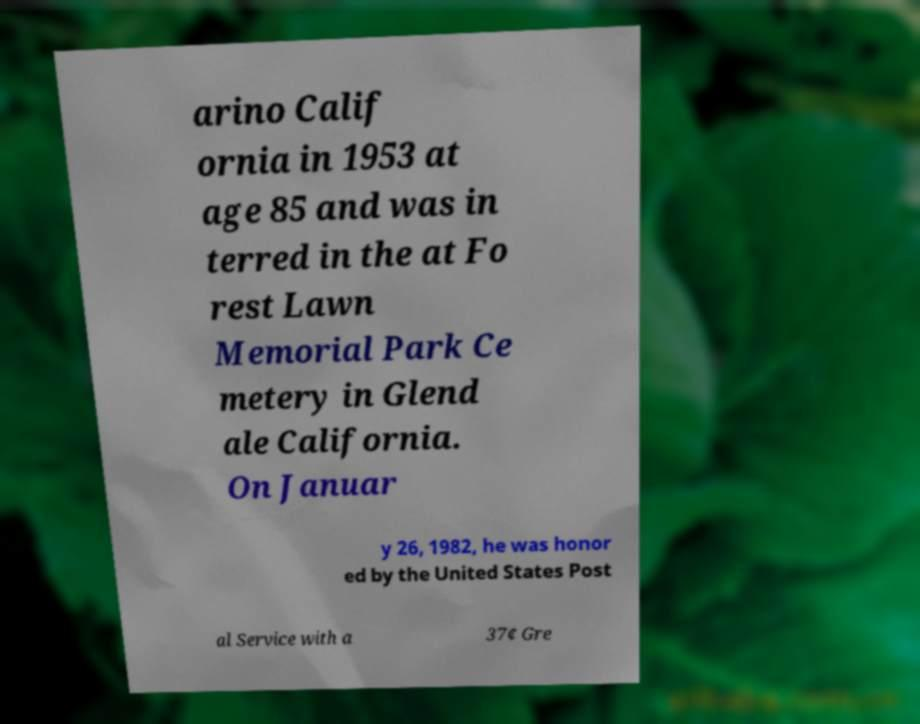Can you read and provide the text displayed in the image?This photo seems to have some interesting text. Can you extract and type it out for me? arino Calif ornia in 1953 at age 85 and was in terred in the at Fo rest Lawn Memorial Park Ce metery in Glend ale California. On Januar y 26, 1982, he was honor ed by the United States Post al Service with a 37¢ Gre 